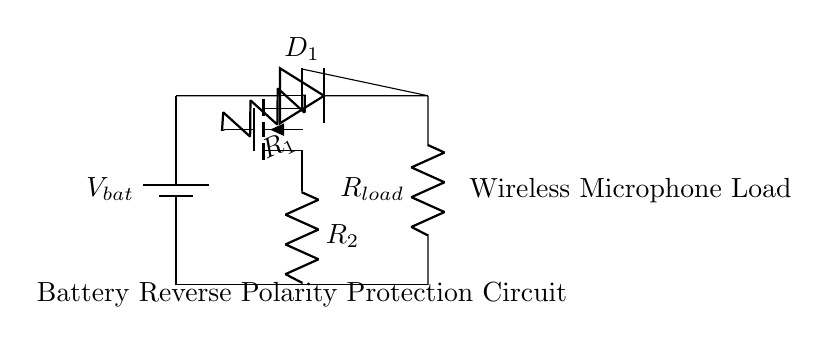What type of protection does this circuit provide? This circuit provides reverse polarity protection by preventing damage from incorrect battery connections. The MOSFET and diode work together to allow the current to flow only when the battery is connected correctly, ensuring that a reversed connection doesn’t affect the load.
Answer: reverse polarity protection What is the function of the diode in this circuit? The diode allows current to flow in one direction and blocks it in the opposite direction. In this circuit, it protects the load by preventing reverse current from reaching it if the battery is connected incorrectly.
Answer: current direction control What components are used in this battery protection circuit? The components include a MOSFET, a diode, two resistors, a battery, and a load resistor. These components work together to manage the current flow and protect the circuit from reverse polarity.
Answer: MOSFET, diode, resistors, battery, load Which component acts as an electronic switch? The MOSFET acts as an electronic switch. It enables or disables the flow of current based on the connection of the battery, facilitating protection against polarity reversal.
Answer: MOSFET What is the role of resistor R2 in the circuit? Resistor R2 is likely placed to limit the current flowing to the MOSFET's source, helping ensure that the MOSFET operates within its safe limits. It contributes to the overall function of the circuit by managing current levels.
Answer: current limiting How does the circuit react if the battery is connected in reverse? If the battery is connected in reverse, the diode D1 will block current flow, preventing the load from receiving power. The MOSFET will remain off, ensuring no current reaches the wireless microphone load, thus protecting it from damage.
Answer: it blocks current flow 